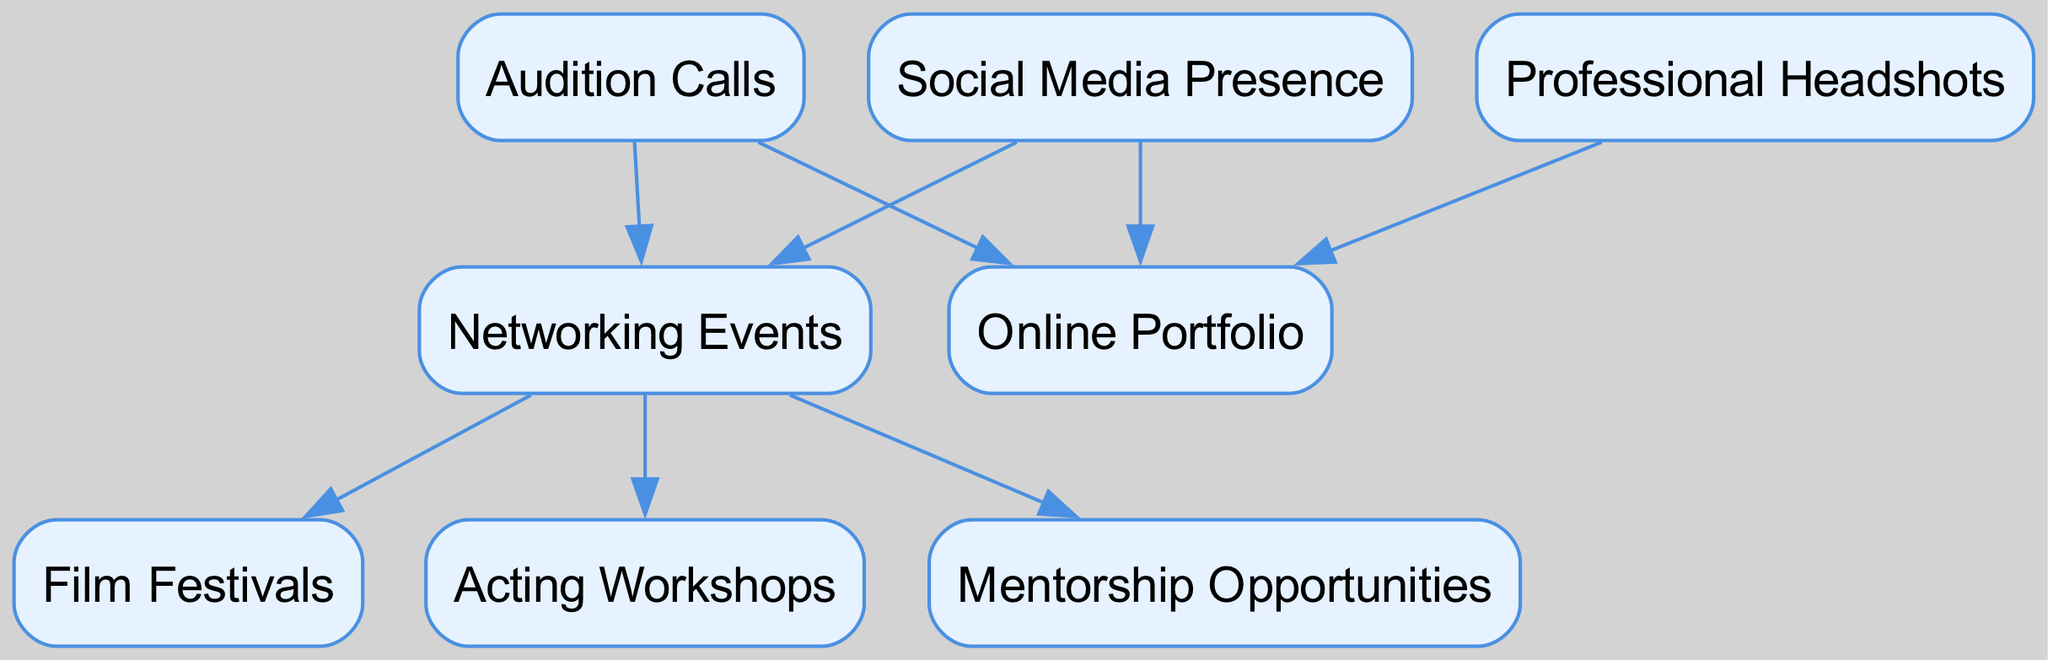What is the total number of nodes in the diagram? By counting each individual node in the diagram, we observe there are eight distinct nodes representing different personal branding strategies for an aspiring actor.
Answer: 8 Which node is connected to 'Social Media Presence'? 'Social Media Presence' points to two other nodes: 'Online Portfolio' and 'Networking Events'. Thus, the nodes connected to it are 'Online Portfolio' and 'Networking'.
Answer: Online Portfolio, Networking How many edges are there in total? We can count each connection between nodes, which represents an edge. There are a total of seven edges illustrated in the diagram, showing the relationships between various branding strategies.
Answer: 7 What is the destination node of the 'Networking Events' node? From the 'Networking Events' node, there are three connected nodes: 'Film Festivals', 'Acting Workshops', and 'Mentorship Opportunities'. Therefore, the destination nodes of 'Networking Events' include these three strategies.
Answer: Film Festivals, Acting Workshops, Mentorship Opportunities Which node has the most connections (edges) directed away from it? By examining all nodes, 'Networking Events' has three outgoing edges connecting to 'Film Festivals', 'Acting Workshops', and 'Mentorship Opportunities', making it the node with the most connections directed away from it.
Answer: Networking Events How are 'Audition Calls' related to 'Social Media Presence'? Looking at the edges, 'Audition Calls' has no direct connection to 'Social Media Presence', but both nodes are ultimately part of strategies that can lead to networking opportunities and an online portfolio. Thus, the relationship is not direct but they are related through networking strategies.
Answer: No direct connection What is the significance of the 'Online Portfolio' in this diagram? The 'Online Portfolio' is linked as a destination node from both 'Social Media Presence' and 'Headshots', indicating it is an important component in showcasing an actor's work and image to potential employers.
Answer: Important component Which two nodes are direct sources leading to 'Networking Events'? The nodes that lead directly to 'Networking Events' are 'Social Media Presence' and 'Audition Calls', suggesting that both strategies help create networking opportunities for the aspiring actor.
Answer: Social Media Presence, Audition Calls 